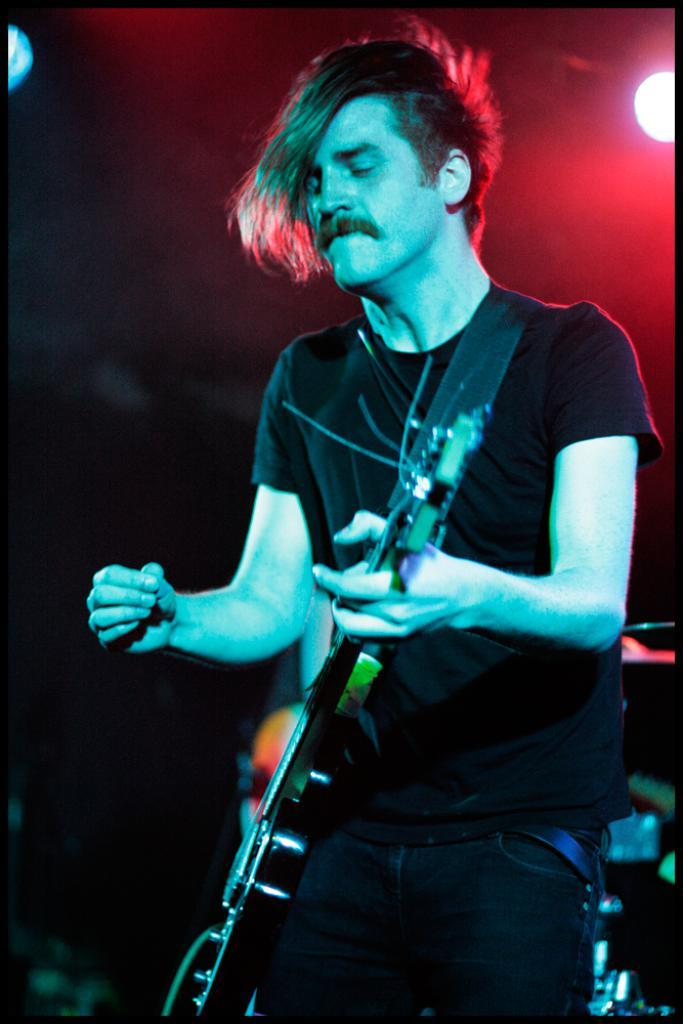Who is present in the image? There is a man in the image. What is the man doing in the image? The man is standing in the image. What object is the man holding in the image? The man is holding a guitar in the image. What can be seen in the background of the image? There is light visible in the background of the image. Where is the desk located in the image? There is no desk present in the image. Can you see a frog on the man's shoulder in the image? There is no frog visible in the image. 